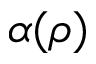<formula> <loc_0><loc_0><loc_500><loc_500>\alpha ( \rho )</formula> 